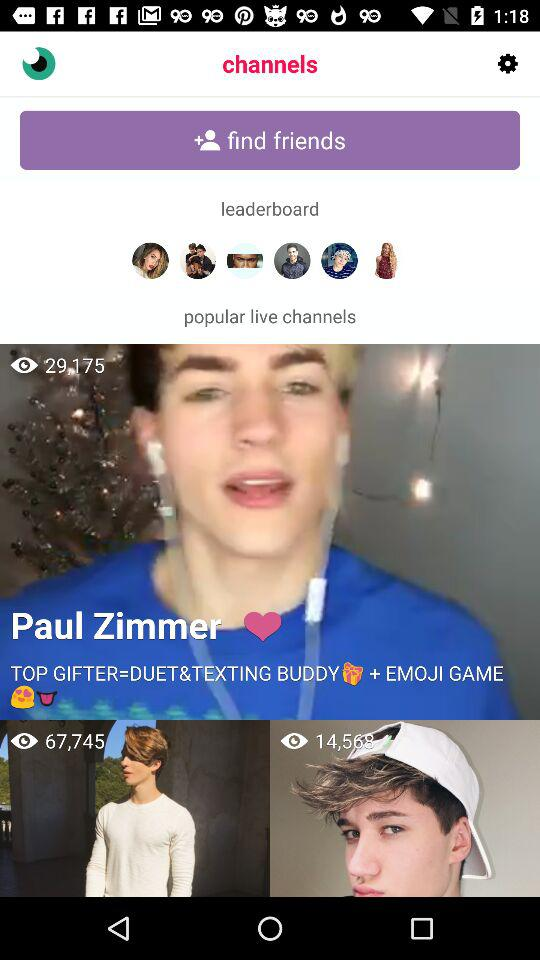How many people are watching the live stream by Paul Zimmer? The number of people that are watching the live stream by Paul Zimmer is 29,175. 